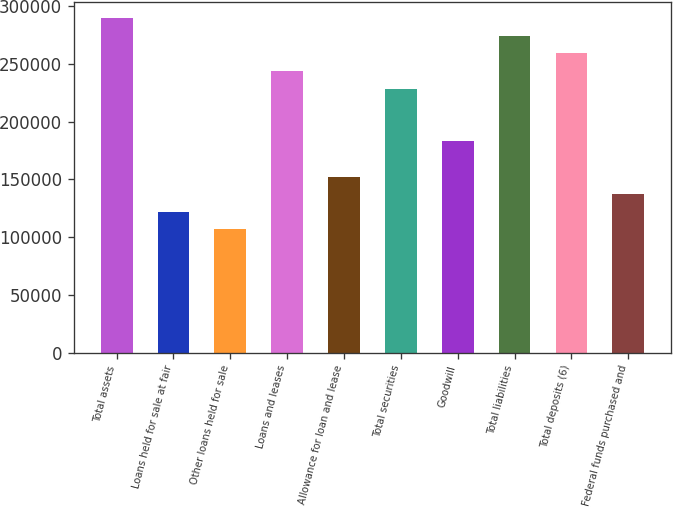<chart> <loc_0><loc_0><loc_500><loc_500><bar_chart><fcel>Total assets<fcel>Loans held for sale at fair<fcel>Other loans held for sale<fcel>Loans and leases<fcel>Allowance for loan and lease<fcel>Total securities<fcel>Goodwill<fcel>Total liabilities<fcel>Total deposits (6)<fcel>Federal funds purchased and<nl><fcel>289438<fcel>121869<fcel>106635<fcel>243737<fcel>152336<fcel>228504<fcel>182803<fcel>274204<fcel>258971<fcel>137102<nl></chart> 